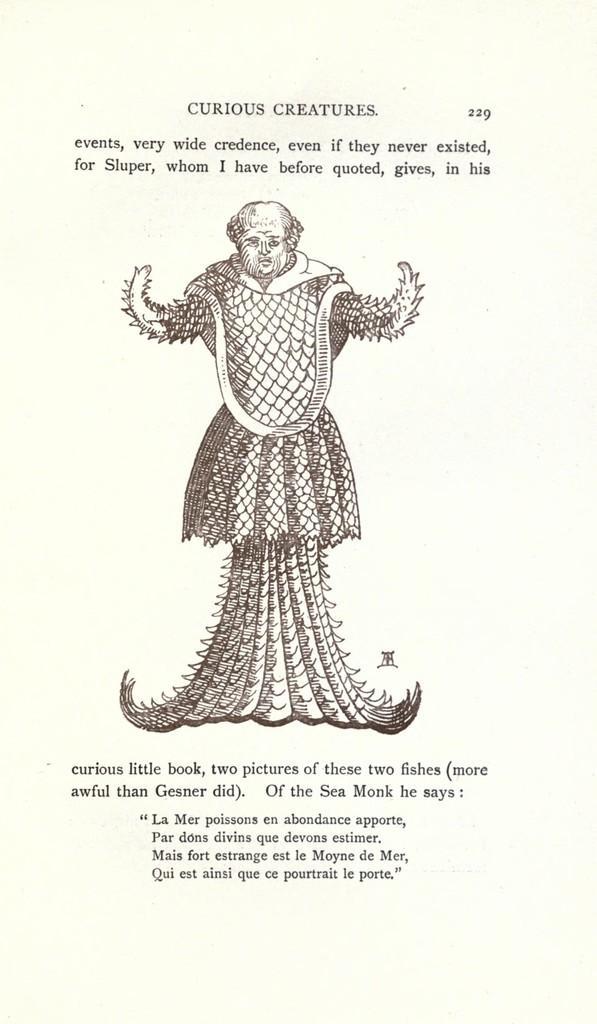In one or two sentences, can you explain what this image depicts? In this image I can see the page of the book which is cream in color. On the page I can see the sketch of a person and few words written with black color. 